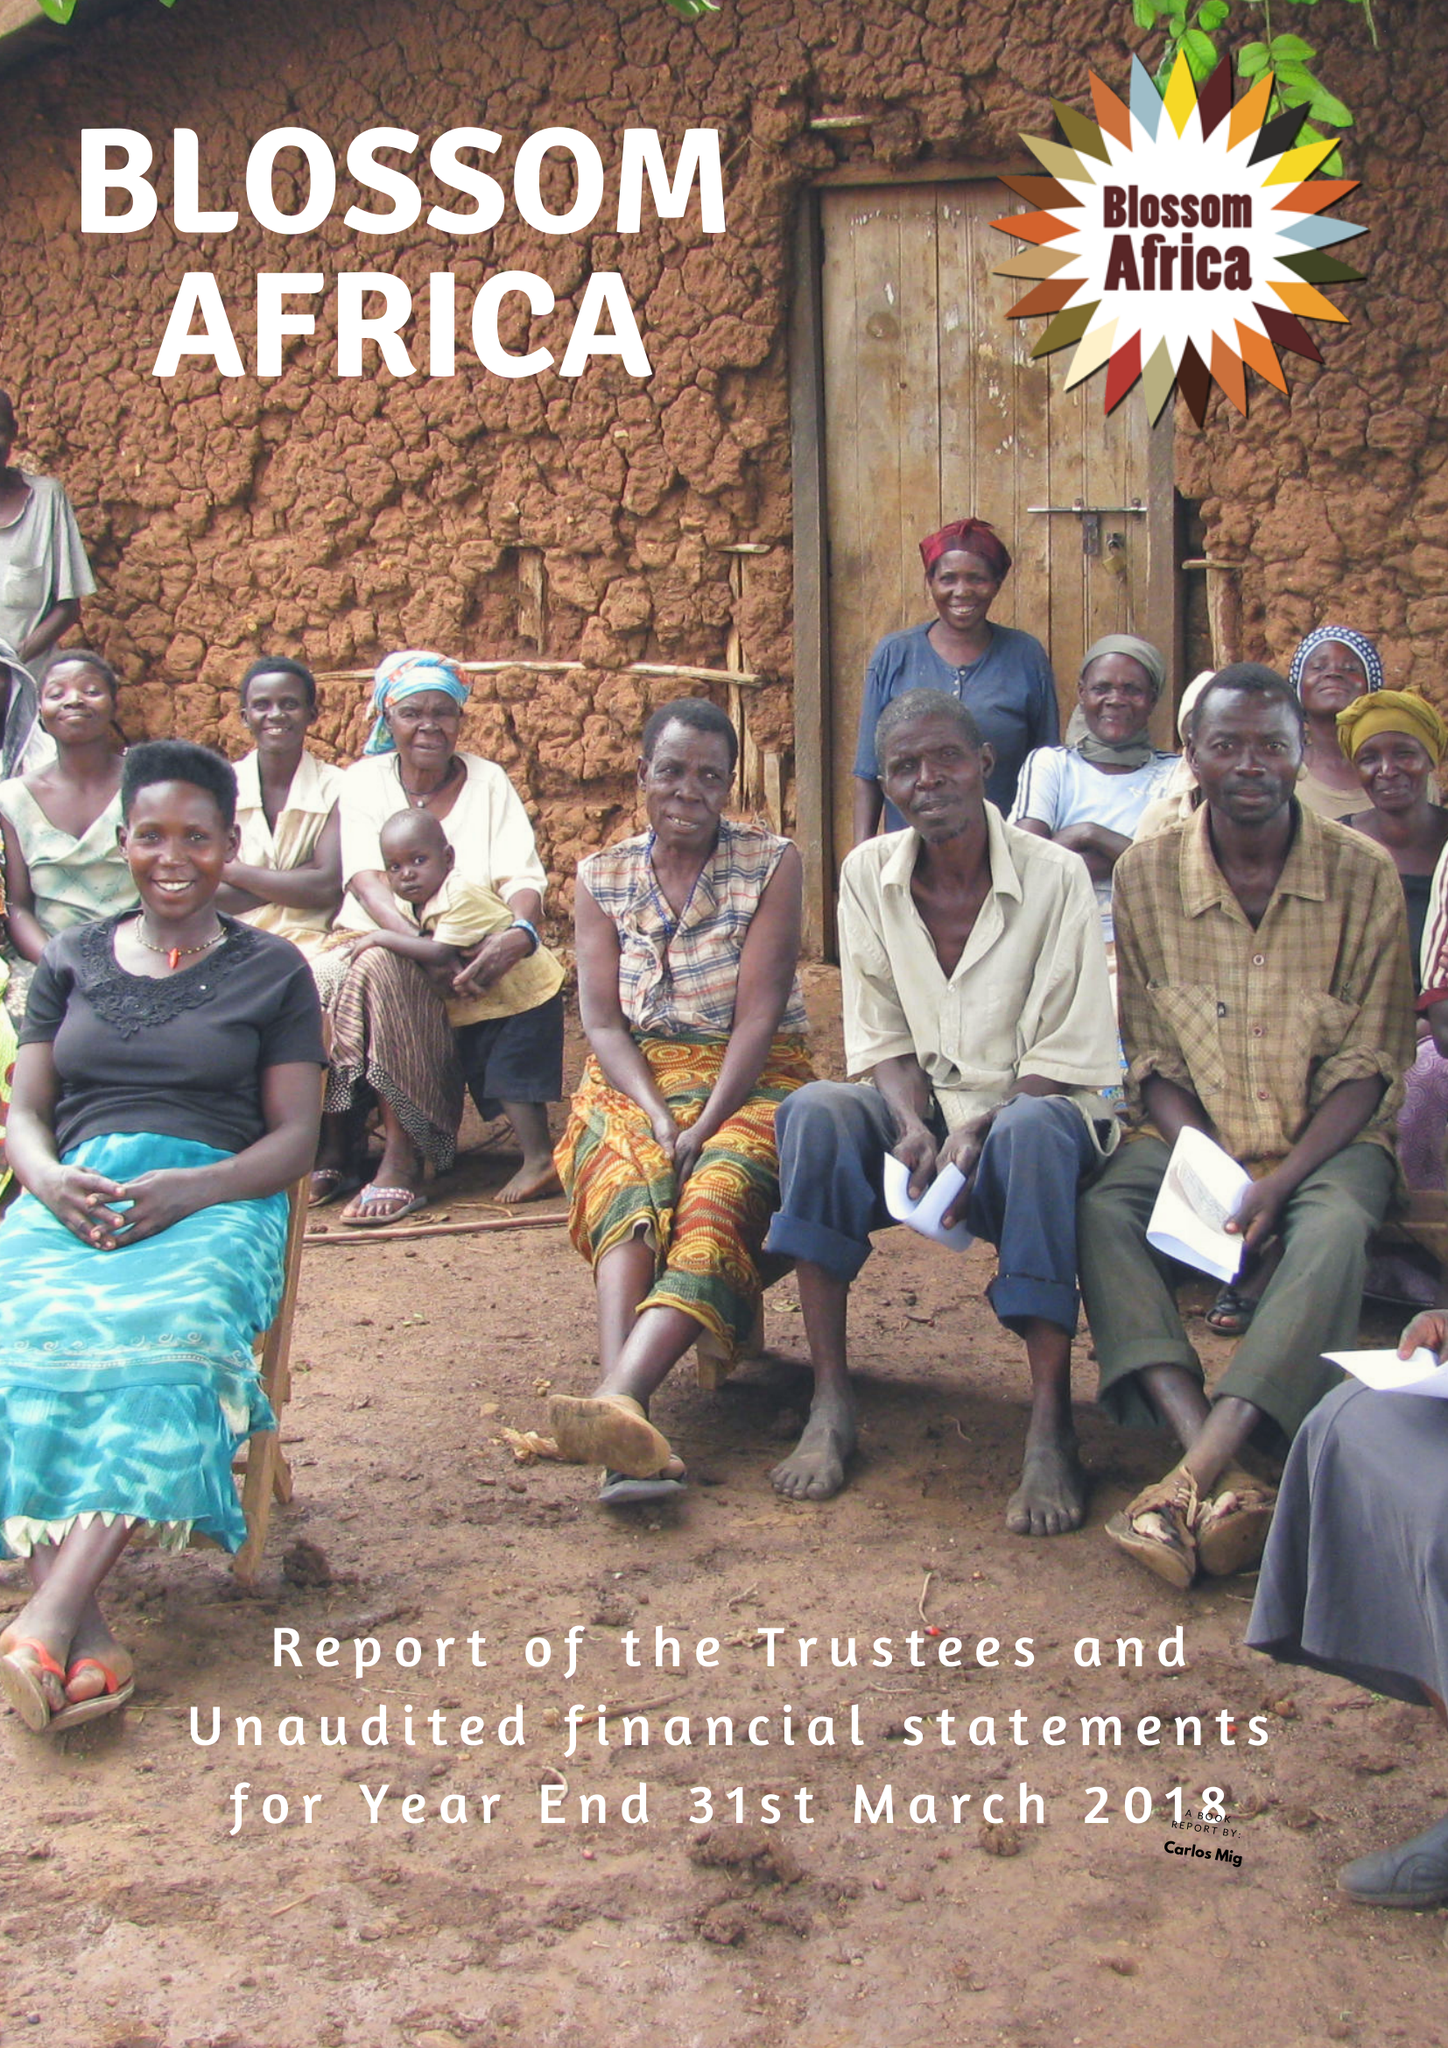What is the value for the charity_number?
Answer the question using a single word or phrase. 1161993 